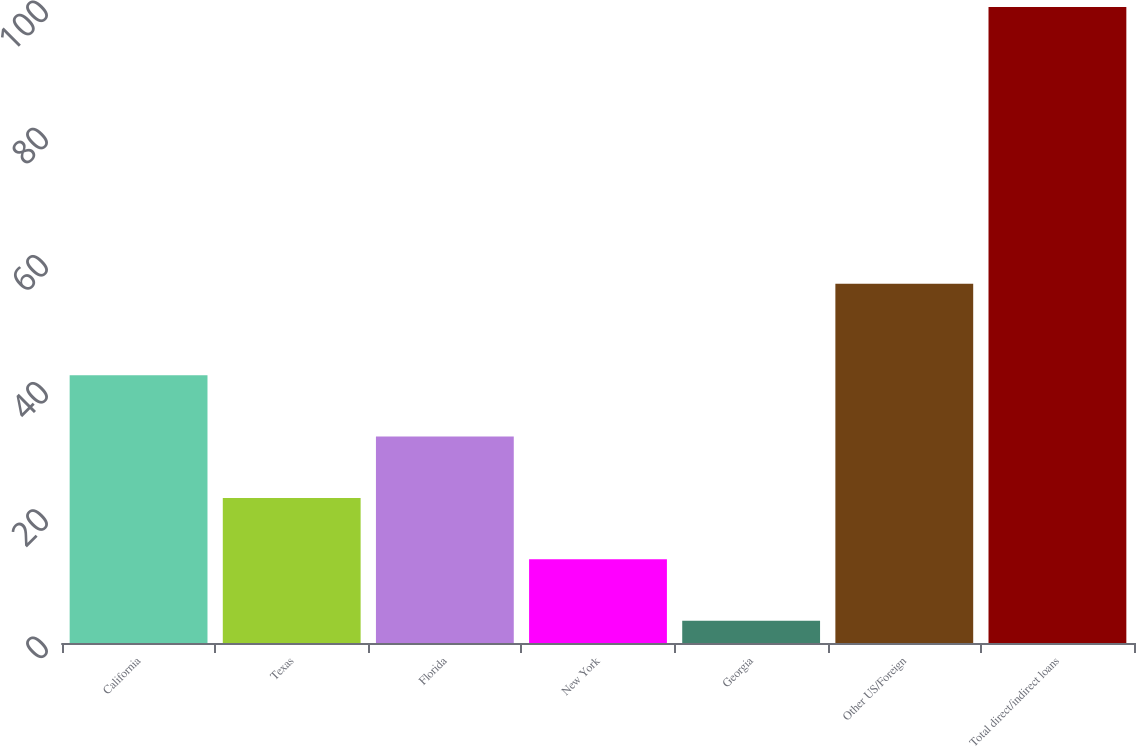Convert chart. <chart><loc_0><loc_0><loc_500><loc_500><bar_chart><fcel>California<fcel>Texas<fcel>Florida<fcel>New York<fcel>Georgia<fcel>Other US/Foreign<fcel>Total direct/indirect loans<nl><fcel>42.1<fcel>22.8<fcel>32.45<fcel>13.15<fcel>3.5<fcel>56.5<fcel>100<nl></chart> 